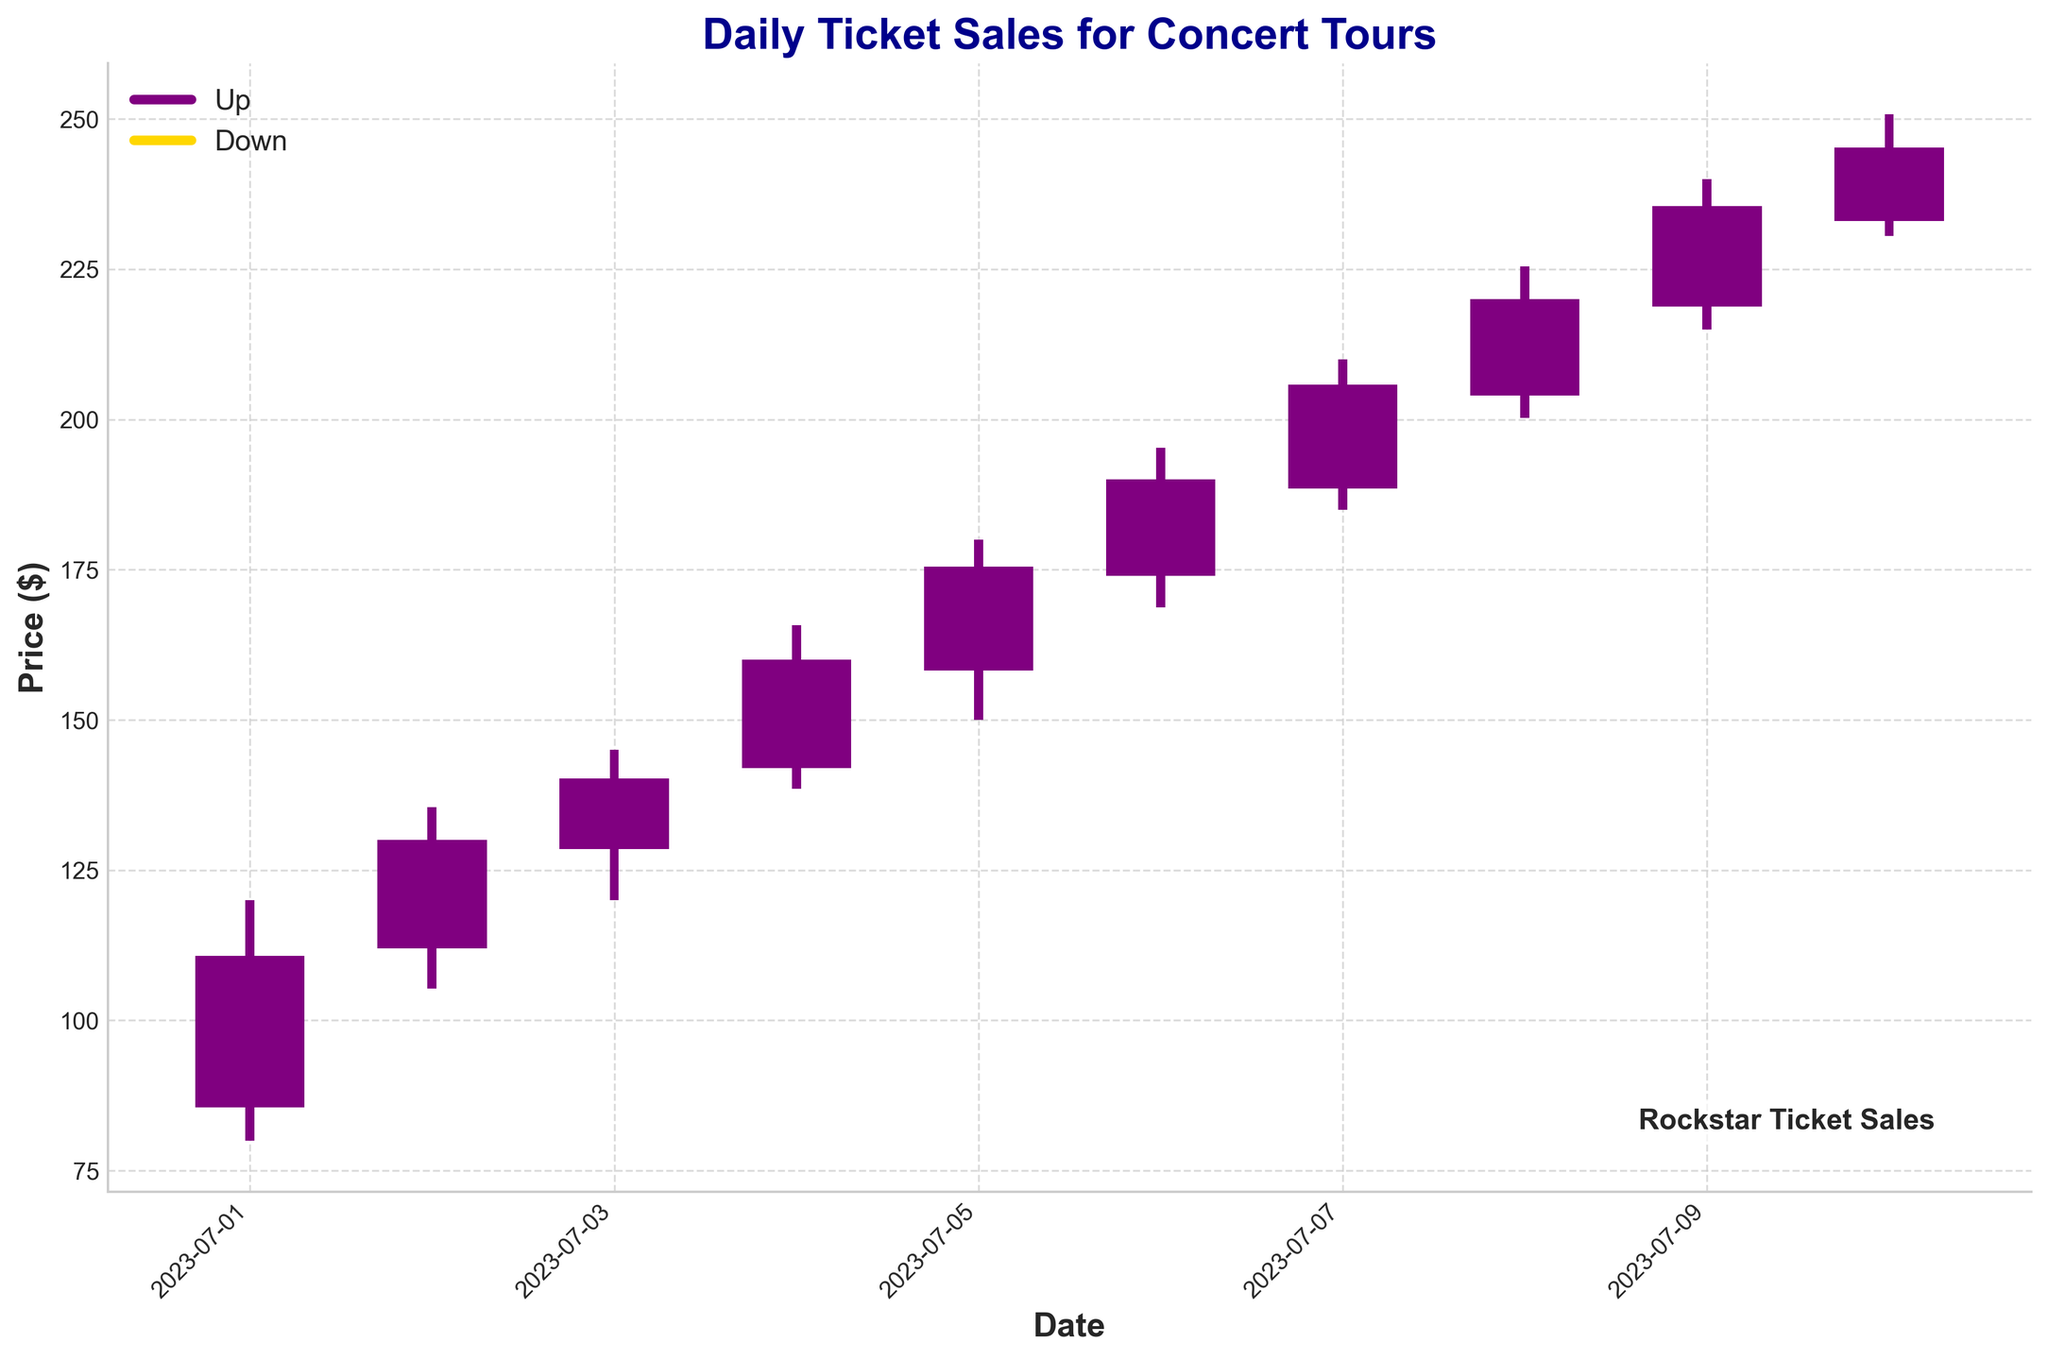What's the title of the chart? The title is often placed prominently at the top of the chart, which in this case is 'Daily Ticket Sales for Concert Tours'.
Answer: Daily Ticket Sales for Concert Tours How many total days are presented in the figure? By looking at the x-axis, which represents dates, and counting the visual bars, we can see that 10 days are covered from July 1, 2023, to July 10, 2023.
Answer: 10 Which day shows the highest price and what is it? The highest price refers to the tallest point on the chart. On July 10, the highest price reached is represented by the top of the bar, which is $250.75.
Answer: July 10, $250.75 For which days did the price go up compared to the opening price? Upward trends are shown in purple bars. Counting these, prices went up on July 1, July 2, July 3, July 4, July 5, July 6, July 7, July 8, July 9, and July 10.
Answer: All days What was the opening price on July 5 compared to its closing price? The opening and closing prices for July 5 are shown by the bottom and top of the bar respectively. On July 5, the opening price is $158.25 and the closing price is $175.50.
Answer: $158.25 (open), $175.50 (close) Which date exhibits the largest difference between the opening and closing prices? To find this, calculate the difference between opening and closing prices for each day. As the chart shows on July 5, the price difference is $175.50 - $158.25 = $17.25, which is the largest difference.
Answer: July 5 Was there any day when the closing price was lower than the opening price? Downward trends are shown in gold bars. By checking the visual, none of the bars show gold on both ends across the bottom, indicating no days had a lower closing than opening price.
Answer: No What was the range (highest to lowest) on July 4? The range is determined by the highest and lowest price points for the day. On July 4, the highest price is $165.75, and the lowest is $138.50. The range is $165.75 - $138.50 = $27.25.
Answer: $27.25 How many days did the high price remain above $200? High prices are the top end of the bars. Counting those days that have high prices crossing $200, we get July 6, July 7, July 8, July 9, and July 10, which makes five days.
Answer: 5 Which day has the lowest low, and what is the value? The lowest price across all days is shown by the bottom end of the bars. On July 1, the lowest price reaches down to $80.00, which is the lowest among all days.
Answer: July 1, $80.00 